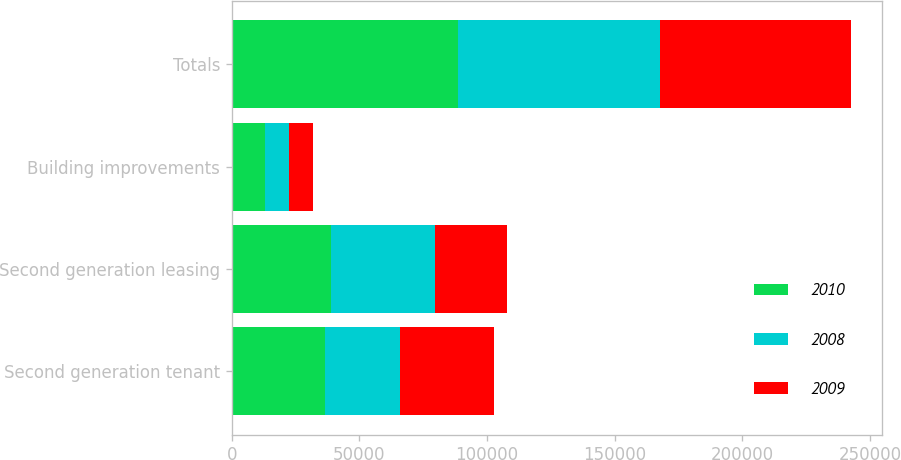Convert chart to OTSL. <chart><loc_0><loc_0><loc_500><loc_500><stacked_bar_chart><ecel><fcel>Second generation tenant<fcel>Second generation leasing<fcel>Building improvements<fcel>Totals<nl><fcel>2010<fcel>36676<fcel>39090<fcel>12957<fcel>88723<nl><fcel>2008<fcel>29321<fcel>40412<fcel>9321<fcel>79054<nl><fcel>2009<fcel>36885<fcel>28205<fcel>9724<fcel>74814<nl></chart> 